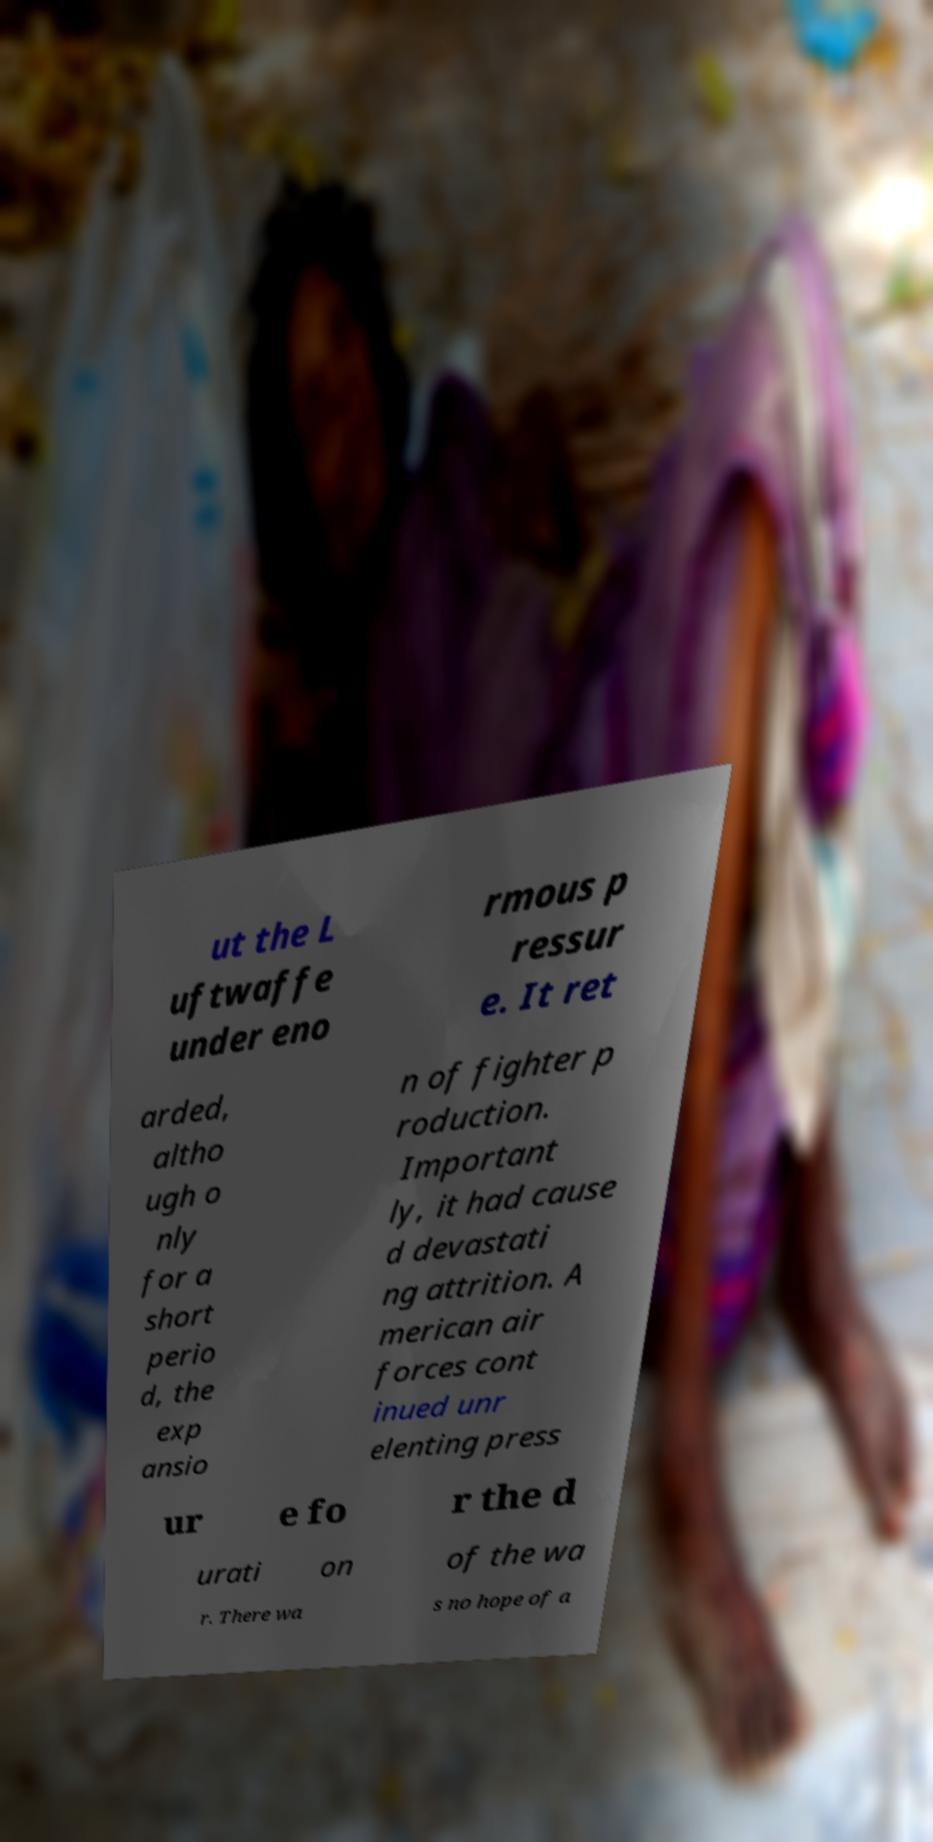Please identify and transcribe the text found in this image. ut the L uftwaffe under eno rmous p ressur e. It ret arded, altho ugh o nly for a short perio d, the exp ansio n of fighter p roduction. Important ly, it had cause d devastati ng attrition. A merican air forces cont inued unr elenting press ur e fo r the d urati on of the wa r. There wa s no hope of a 